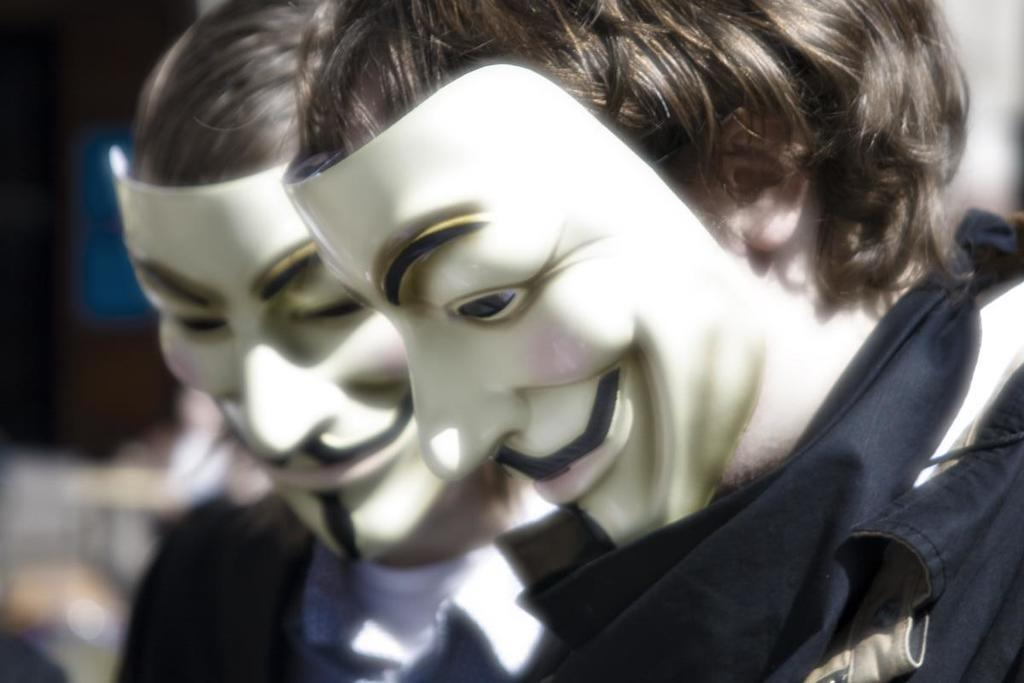How many people are in the image? There are two persons in the image. What are the persons wearing on their faces? The persons are wearing masks. Can you describe the background of the image? The background of the image is blurred. What is the value of the number on the committee's sign in the image? There is no committee or sign present in the image. 